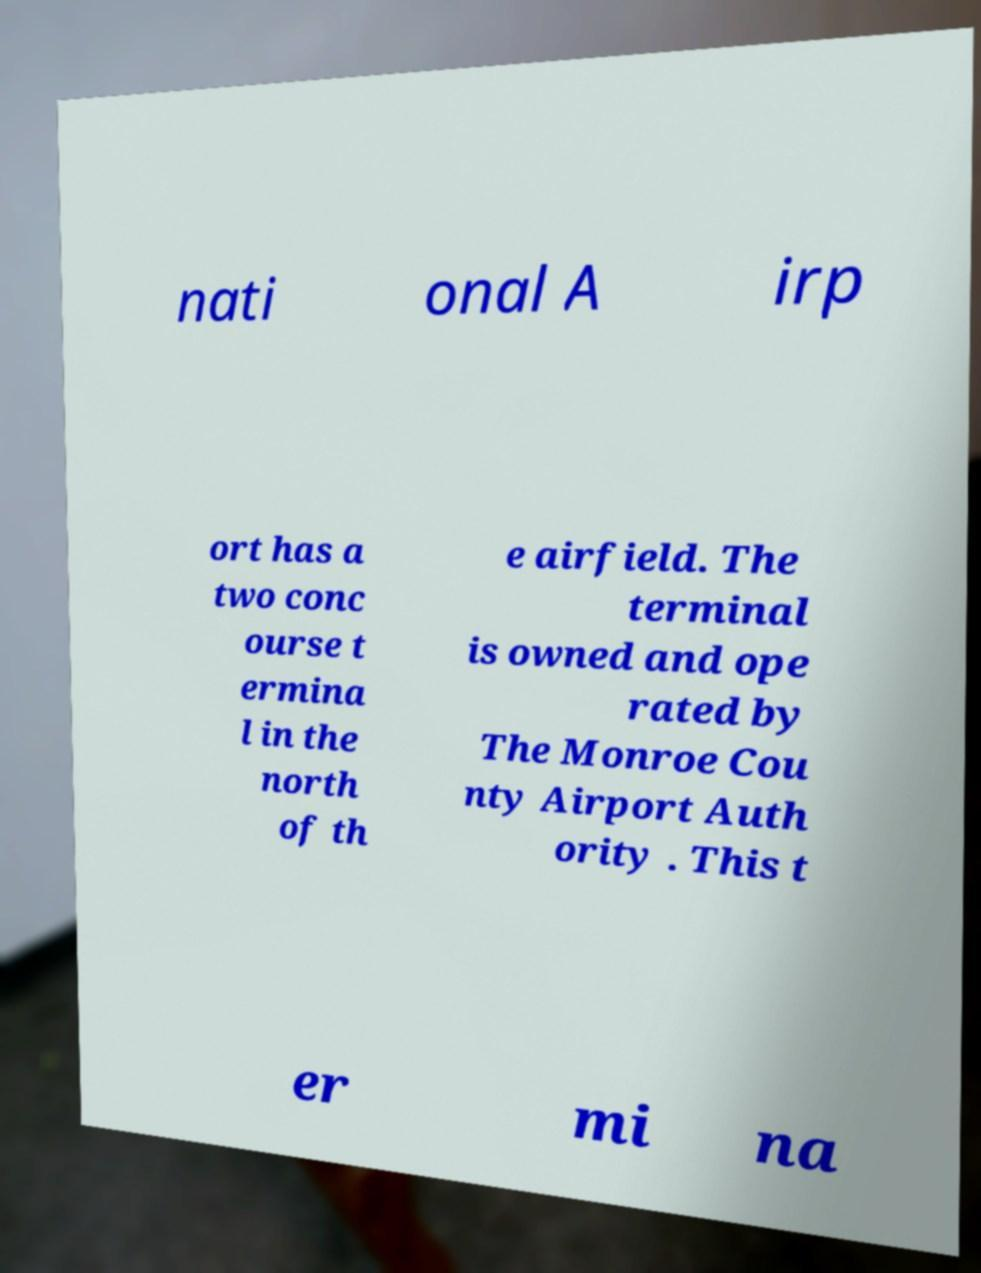Could you extract and type out the text from this image? nati onal A irp ort has a two conc ourse t ermina l in the north of th e airfield. The terminal is owned and ope rated by The Monroe Cou nty Airport Auth ority . This t er mi na 